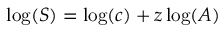Convert formula to latex. <formula><loc_0><loc_0><loc_500><loc_500>\log ( S ) = \log ( c ) + z \log ( A )</formula> 